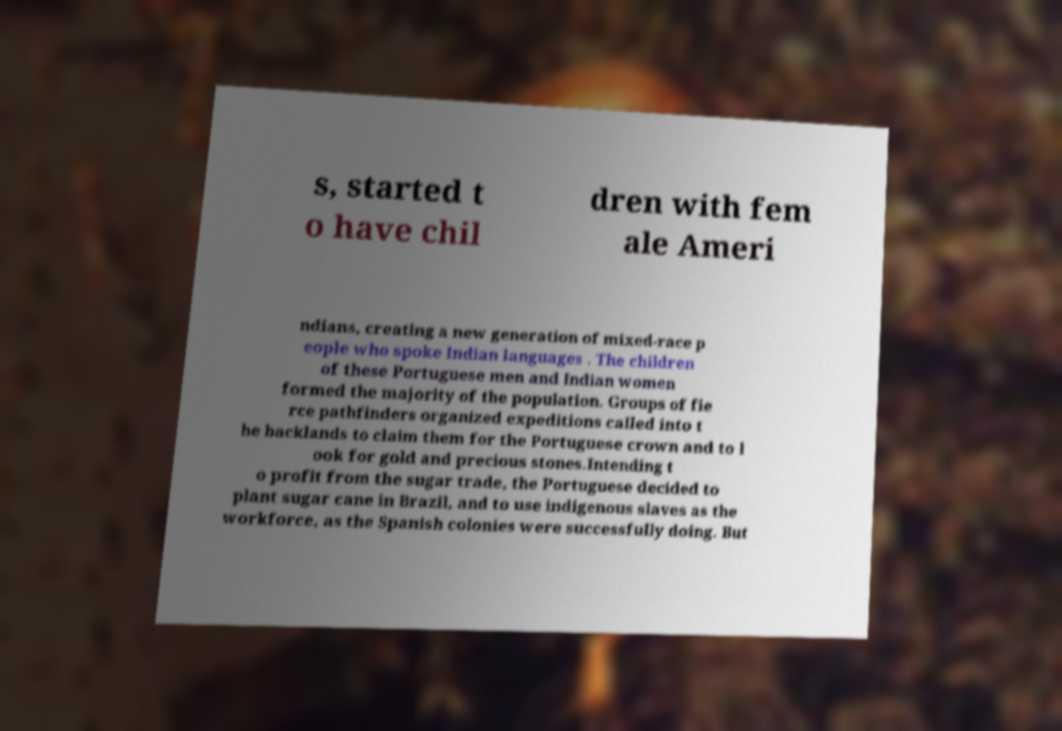Please identify and transcribe the text found in this image. s, started t o have chil dren with fem ale Ameri ndians, creating a new generation of mixed-race p eople who spoke Indian languages . The children of these Portuguese men and Indian women formed the majority of the population. Groups of fie rce pathfinders organized expeditions called into t he backlands to claim them for the Portuguese crown and to l ook for gold and precious stones.Intending t o profit from the sugar trade, the Portuguese decided to plant sugar cane in Brazil, and to use indigenous slaves as the workforce, as the Spanish colonies were successfully doing. But 